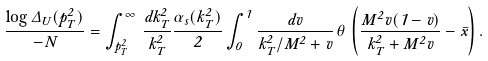<formula> <loc_0><loc_0><loc_500><loc_500>\frac { \log \Delta _ { U } ( p _ { T } ^ { 2 } ) } { - N } = \int _ { p _ { T } ^ { 2 } } ^ { \infty } \, \frac { d k _ { T } ^ { 2 } } { k _ { T } ^ { 2 } } \frac { \alpha _ { s } ( k _ { T } ^ { 2 } ) } { 2 } \int _ { 0 } ^ { 1 } \frac { d v } { k _ { T } ^ { 2 } / M ^ { 2 } + v } \, \theta \, \left ( \frac { M ^ { 2 } v ( 1 - v ) } { k _ { T } ^ { 2 } + M ^ { 2 } v } - \bar { x } \right ) .</formula> 